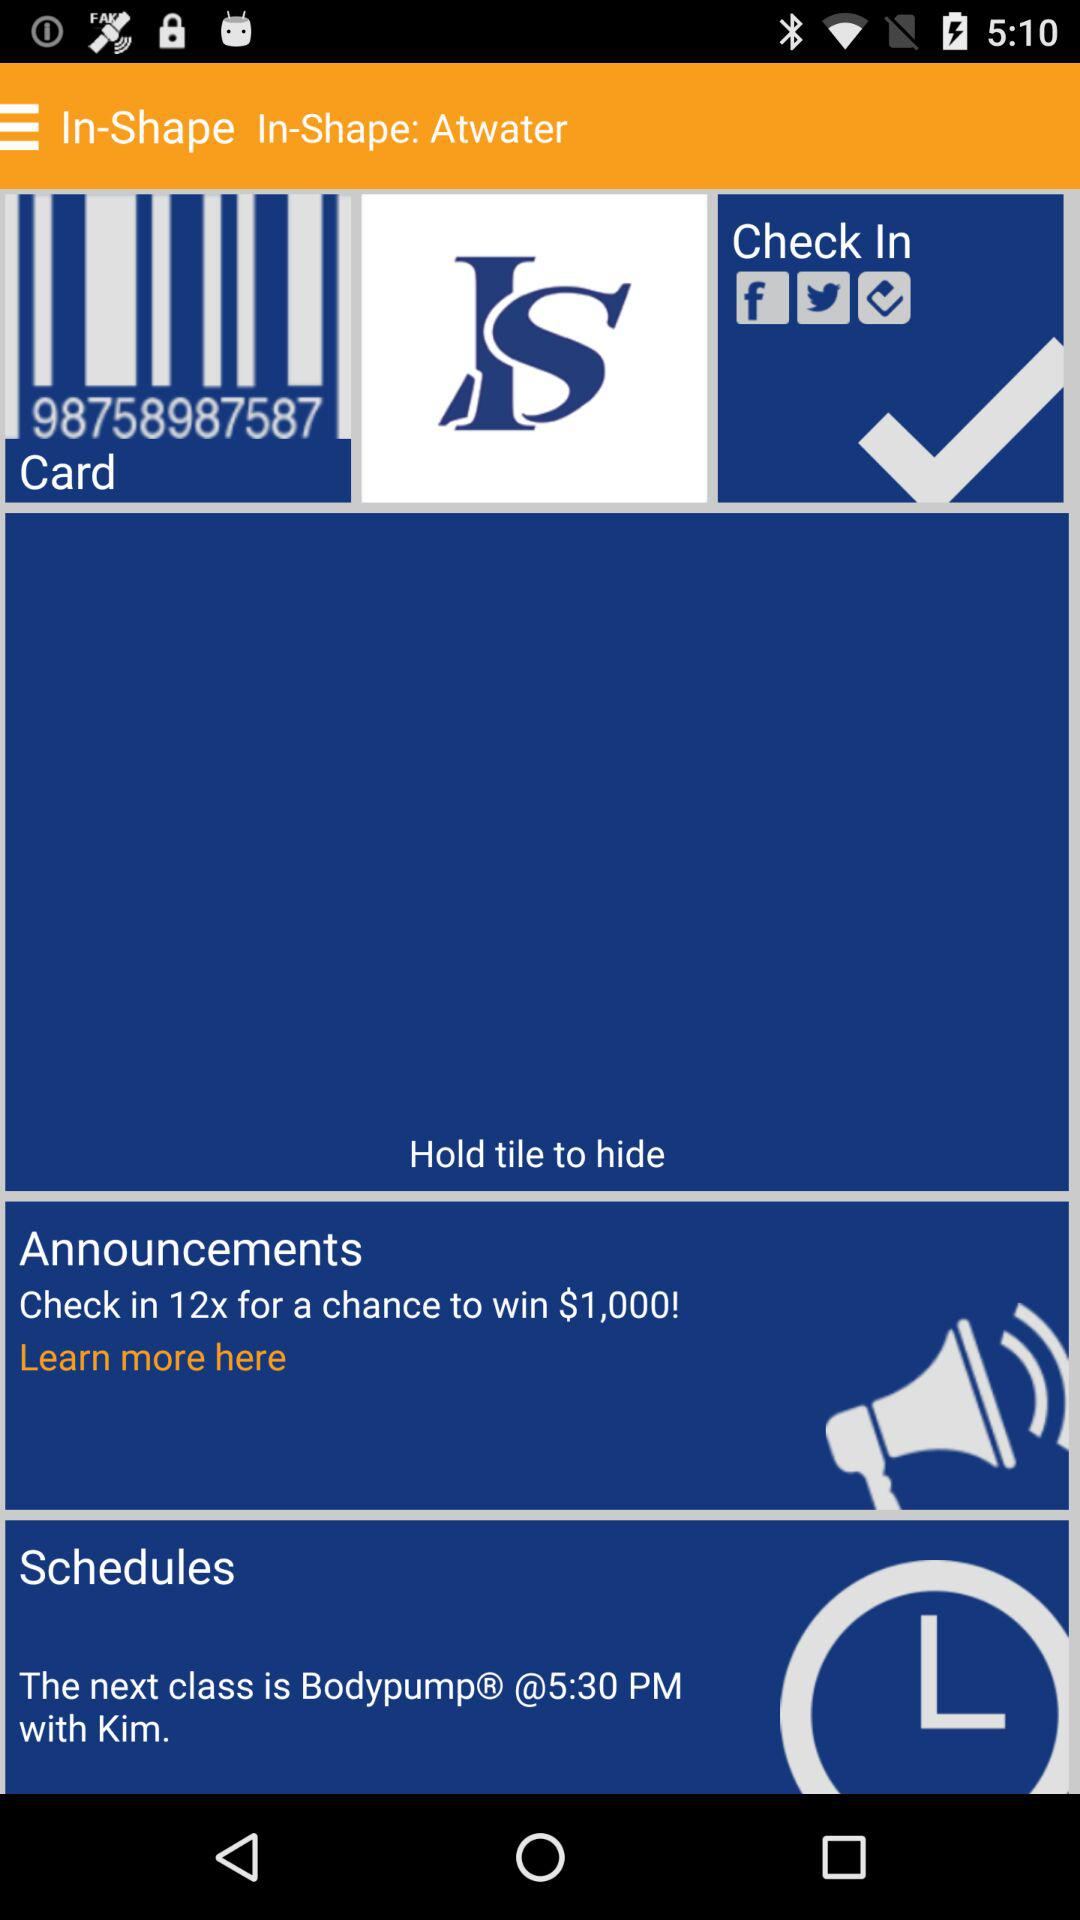Who will take the class? The class will be taken by Kim. 